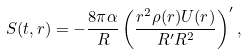<formula> <loc_0><loc_0><loc_500><loc_500>S ( t , r ) = - \frac { 8 \pi \alpha } { R } \left ( \frac { r ^ { 2 } \rho ( r ) U ( r ) } { R ^ { \prime } R ^ { 2 } } \right ) ^ { \prime } ,</formula> 